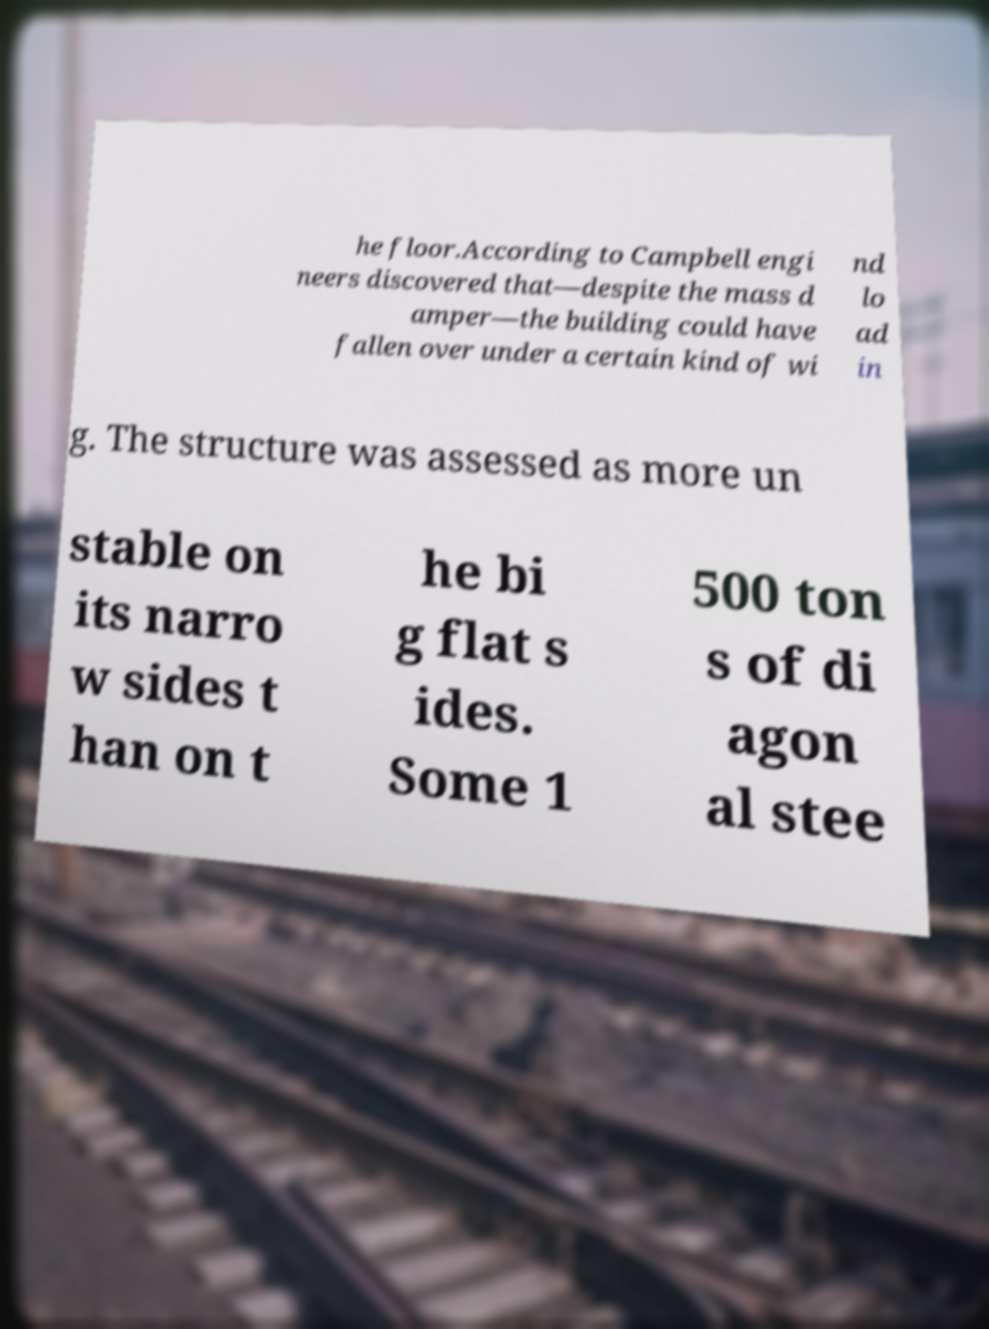Can you read and provide the text displayed in the image?This photo seems to have some interesting text. Can you extract and type it out for me? he floor.According to Campbell engi neers discovered that—despite the mass d amper—the building could have fallen over under a certain kind of wi nd lo ad in g. The structure was assessed as more un stable on its narro w sides t han on t he bi g flat s ides. Some 1 500 ton s of di agon al stee 